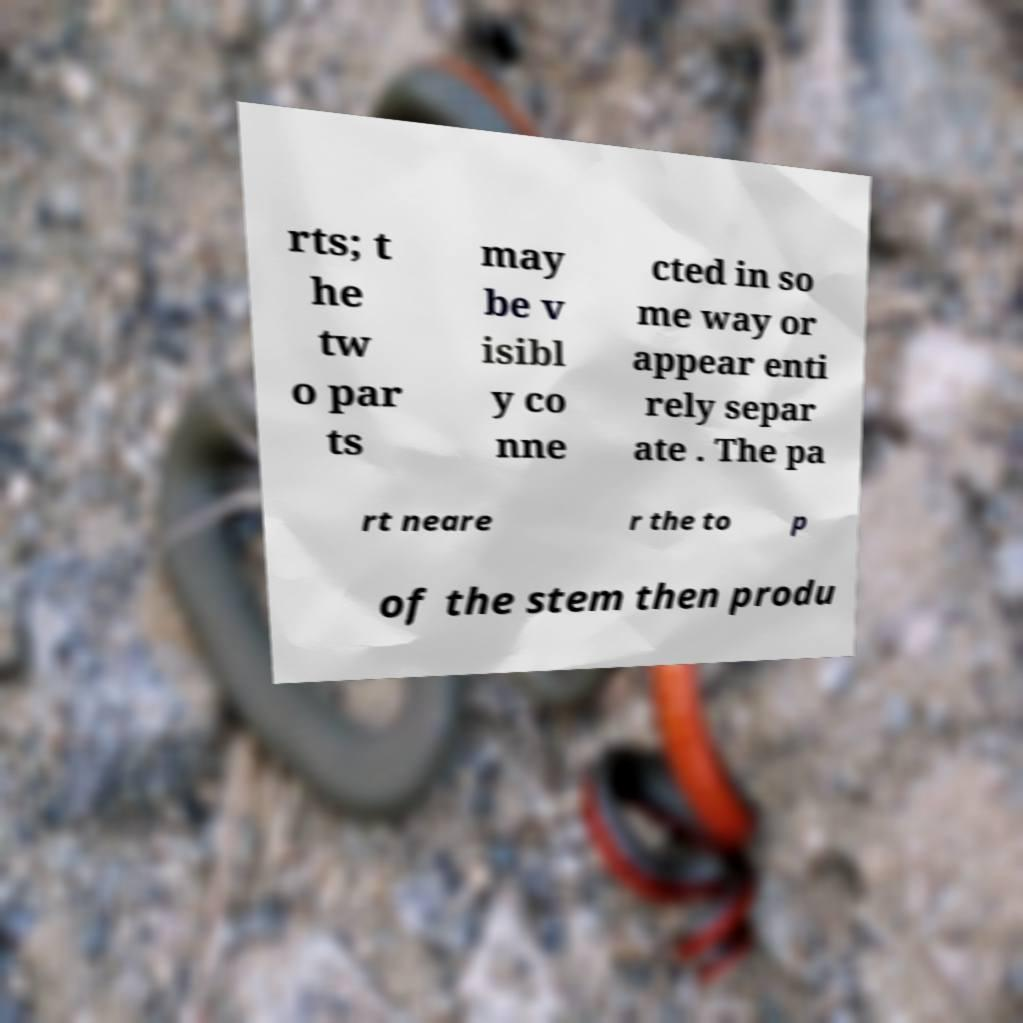Can you accurately transcribe the text from the provided image for me? rts; t he tw o par ts may be v isibl y co nne cted in so me way or appear enti rely separ ate . The pa rt neare r the to p of the stem then produ 